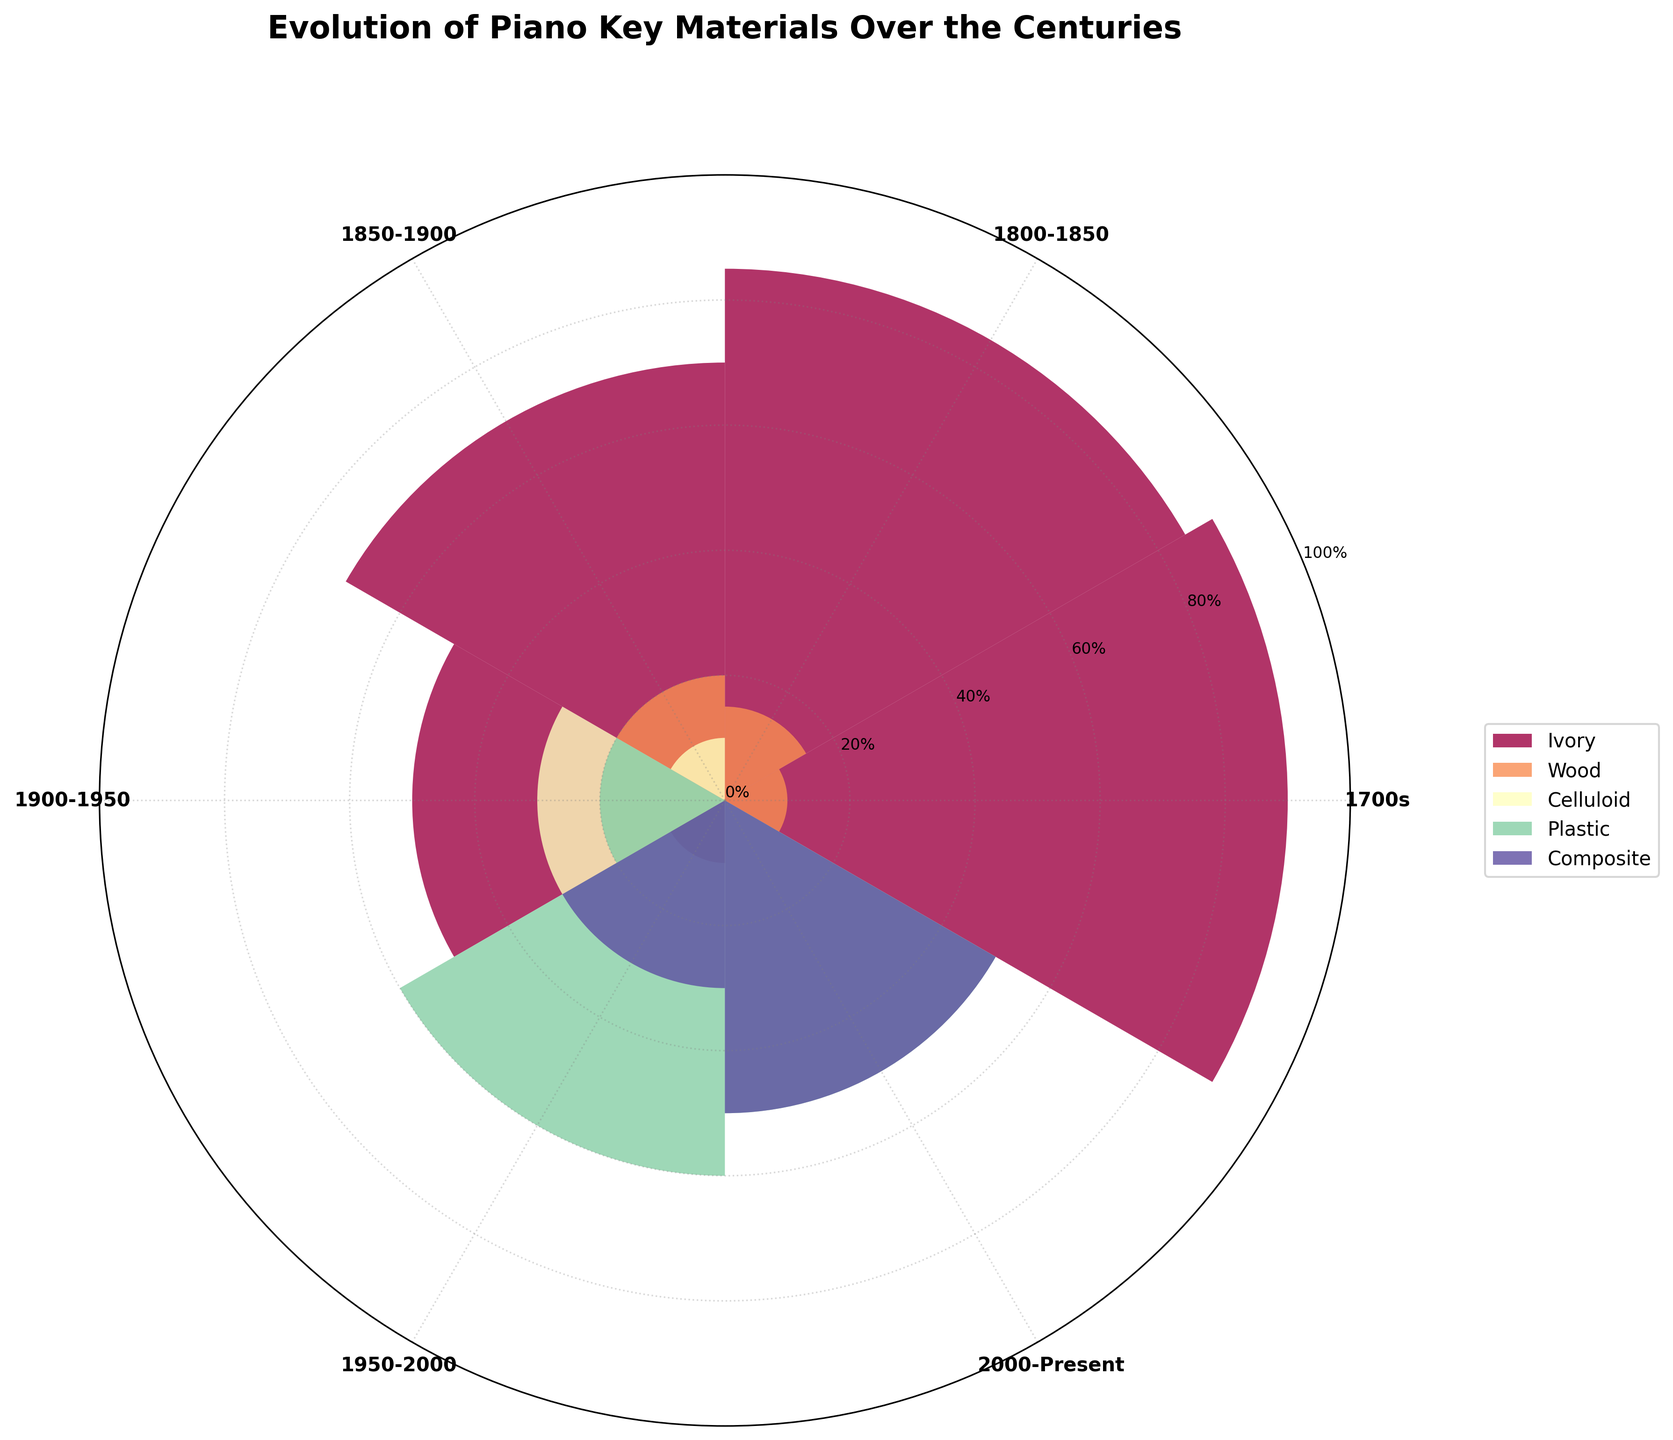What's the title of the figure? The title of the figure is located at the top and reads "Evolution of Piano Key Materials Over the Centuries."
Answer: Evolution of Piano Key Materials Over the Centuries Which material was most commonly used in the 1700s? In the 1700s, the segment representing Ivory is the largest, indicating it was the most commonly used material.
Answer: Ivory How did the proportion of Ivory change from the 1700s to 1900-1950? In the 1700s, the proportion of Ivory was 90%. It dropped to 85% during 1800-1850, 70% during 1850-1900, and further down to 50% in 1900-1950. This shows a decreasing trend.
Answer: It decreased In which period did Composite materials first appear? Composite materials are represented in the plot starting from the period 1950-2000.
Answer: 1950-2000 Which period shows the highest variety of materials used? The 1900-1950 period shows the highest variety of materials with Ivory, Celluloid, and Plastic all being used.
Answer: 1900-1950 Compare the use of Plastic and Composite materials in the period of 1950-2000. In the period 1950-2000, Plastic was used more (60%) compared to Composite (30%).
Answer: Plastic was used more Which period saw Celluloid materials being used, and what was the highest proportion it reached? Celluloid materials were used during the periods 1850-1900 and 1900-1950, with the highest proportion reaching 30% during 1900-1950.
Answer: 1900-1950, 30% How has the use of Wood changed from the 1700s to the 1850-1900 period? In the 1700s, Wood was 10%. This slightly increased to 15% during 1800-1850 and again to 20% during 1850-1900.
Answer: It increased What can be deduced about the trend in the usage of Plastic materials from 1900-1950 to 2000-Present? From 1900-1950 to 2000-Present, the use of Plastic materials increased from 20% to 50%.
Answer: It increased Compare the proportions of Ivory and Plastic in 2000-Present. In the 2000-Present period, Ivory is no longer used, while Plastic constitutes 50% of the materials.
Answer: Plastic 50%, Ivory 0% 